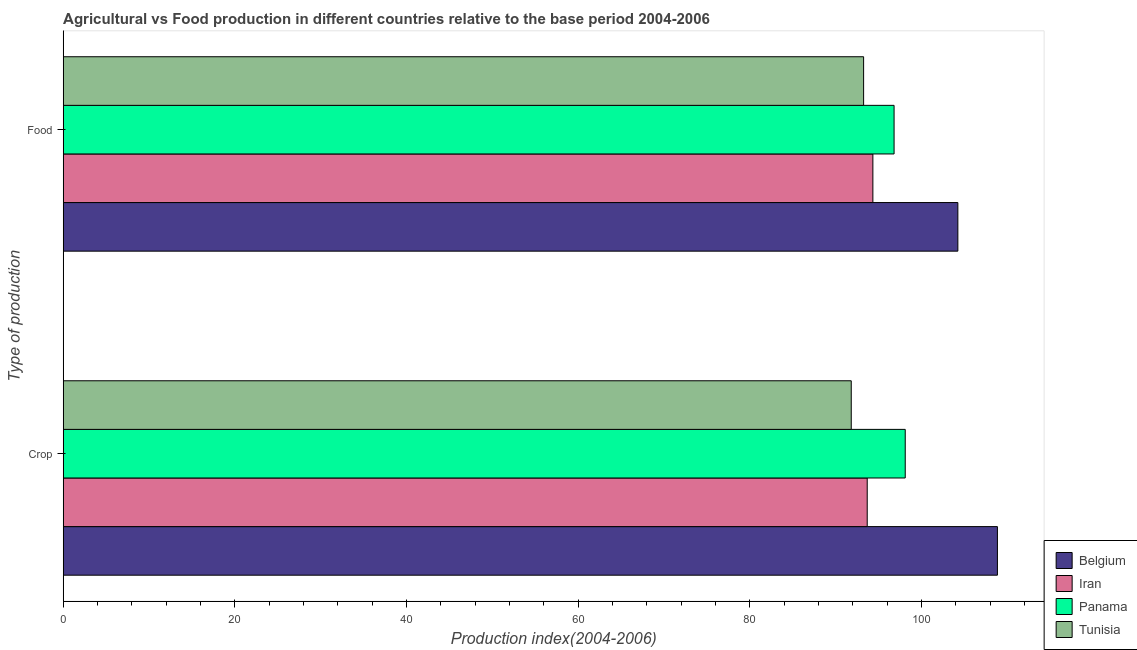Are the number of bars on each tick of the Y-axis equal?
Make the answer very short. Yes. How many bars are there on the 2nd tick from the top?
Keep it short and to the point. 4. How many bars are there on the 2nd tick from the bottom?
Provide a short and direct response. 4. What is the label of the 1st group of bars from the top?
Your response must be concise. Food. What is the crop production index in Belgium?
Offer a terse response. 108.84. Across all countries, what is the maximum crop production index?
Keep it short and to the point. 108.84. Across all countries, what is the minimum crop production index?
Offer a very short reply. 91.81. In which country was the crop production index minimum?
Offer a terse response. Tunisia. What is the total food production index in the graph?
Offer a terse response. 388.61. What is the difference between the crop production index in Tunisia and that in Iran?
Your answer should be very brief. -1.86. What is the difference between the crop production index in Tunisia and the food production index in Iran?
Your answer should be very brief. -2.52. What is the average crop production index per country?
Offer a terse response. 98.11. What is the difference between the food production index and crop production index in Iran?
Give a very brief answer. 0.66. What is the ratio of the crop production index in Belgium to that in Tunisia?
Your response must be concise. 1.19. What does the 4th bar from the top in Crop represents?
Offer a terse response. Belgium. What does the 4th bar from the bottom in Food represents?
Your response must be concise. Tunisia. What is the difference between two consecutive major ticks on the X-axis?
Give a very brief answer. 20. Are the values on the major ticks of X-axis written in scientific E-notation?
Provide a succinct answer. No. How many legend labels are there?
Your response must be concise. 4. What is the title of the graph?
Your response must be concise. Agricultural vs Food production in different countries relative to the base period 2004-2006. Does "South Asia" appear as one of the legend labels in the graph?
Your response must be concise. No. What is the label or title of the X-axis?
Your answer should be compact. Production index(2004-2006). What is the label or title of the Y-axis?
Make the answer very short. Type of production. What is the Production index(2004-2006) of Belgium in Crop?
Your response must be concise. 108.84. What is the Production index(2004-2006) in Iran in Crop?
Your answer should be very brief. 93.67. What is the Production index(2004-2006) in Panama in Crop?
Offer a very short reply. 98.1. What is the Production index(2004-2006) in Tunisia in Crop?
Ensure brevity in your answer.  91.81. What is the Production index(2004-2006) in Belgium in Food?
Your response must be concise. 104.23. What is the Production index(2004-2006) of Iran in Food?
Make the answer very short. 94.33. What is the Production index(2004-2006) of Panama in Food?
Make the answer very short. 96.8. What is the Production index(2004-2006) in Tunisia in Food?
Offer a very short reply. 93.25. Across all Type of production, what is the maximum Production index(2004-2006) of Belgium?
Your response must be concise. 108.84. Across all Type of production, what is the maximum Production index(2004-2006) in Iran?
Offer a terse response. 94.33. Across all Type of production, what is the maximum Production index(2004-2006) of Panama?
Offer a terse response. 98.1. Across all Type of production, what is the maximum Production index(2004-2006) in Tunisia?
Ensure brevity in your answer.  93.25. Across all Type of production, what is the minimum Production index(2004-2006) in Belgium?
Provide a succinct answer. 104.23. Across all Type of production, what is the minimum Production index(2004-2006) of Iran?
Make the answer very short. 93.67. Across all Type of production, what is the minimum Production index(2004-2006) in Panama?
Give a very brief answer. 96.8. Across all Type of production, what is the minimum Production index(2004-2006) in Tunisia?
Your answer should be compact. 91.81. What is the total Production index(2004-2006) of Belgium in the graph?
Your answer should be compact. 213.07. What is the total Production index(2004-2006) of Iran in the graph?
Your response must be concise. 188. What is the total Production index(2004-2006) of Panama in the graph?
Your answer should be compact. 194.9. What is the total Production index(2004-2006) of Tunisia in the graph?
Your answer should be compact. 185.06. What is the difference between the Production index(2004-2006) in Belgium in Crop and that in Food?
Give a very brief answer. 4.61. What is the difference between the Production index(2004-2006) of Iran in Crop and that in Food?
Your answer should be compact. -0.66. What is the difference between the Production index(2004-2006) of Panama in Crop and that in Food?
Provide a short and direct response. 1.3. What is the difference between the Production index(2004-2006) in Tunisia in Crop and that in Food?
Provide a succinct answer. -1.44. What is the difference between the Production index(2004-2006) of Belgium in Crop and the Production index(2004-2006) of Iran in Food?
Give a very brief answer. 14.51. What is the difference between the Production index(2004-2006) in Belgium in Crop and the Production index(2004-2006) in Panama in Food?
Provide a succinct answer. 12.04. What is the difference between the Production index(2004-2006) of Belgium in Crop and the Production index(2004-2006) of Tunisia in Food?
Make the answer very short. 15.59. What is the difference between the Production index(2004-2006) of Iran in Crop and the Production index(2004-2006) of Panama in Food?
Offer a very short reply. -3.13. What is the difference between the Production index(2004-2006) in Iran in Crop and the Production index(2004-2006) in Tunisia in Food?
Your answer should be compact. 0.42. What is the difference between the Production index(2004-2006) of Panama in Crop and the Production index(2004-2006) of Tunisia in Food?
Provide a succinct answer. 4.85. What is the average Production index(2004-2006) of Belgium per Type of production?
Offer a very short reply. 106.53. What is the average Production index(2004-2006) in Iran per Type of production?
Offer a very short reply. 94. What is the average Production index(2004-2006) of Panama per Type of production?
Your answer should be compact. 97.45. What is the average Production index(2004-2006) in Tunisia per Type of production?
Ensure brevity in your answer.  92.53. What is the difference between the Production index(2004-2006) in Belgium and Production index(2004-2006) in Iran in Crop?
Offer a very short reply. 15.17. What is the difference between the Production index(2004-2006) in Belgium and Production index(2004-2006) in Panama in Crop?
Offer a terse response. 10.74. What is the difference between the Production index(2004-2006) of Belgium and Production index(2004-2006) of Tunisia in Crop?
Keep it short and to the point. 17.03. What is the difference between the Production index(2004-2006) in Iran and Production index(2004-2006) in Panama in Crop?
Make the answer very short. -4.43. What is the difference between the Production index(2004-2006) of Iran and Production index(2004-2006) of Tunisia in Crop?
Your answer should be very brief. 1.86. What is the difference between the Production index(2004-2006) in Panama and Production index(2004-2006) in Tunisia in Crop?
Your answer should be compact. 6.29. What is the difference between the Production index(2004-2006) in Belgium and Production index(2004-2006) in Panama in Food?
Offer a very short reply. 7.43. What is the difference between the Production index(2004-2006) in Belgium and Production index(2004-2006) in Tunisia in Food?
Offer a terse response. 10.98. What is the difference between the Production index(2004-2006) of Iran and Production index(2004-2006) of Panama in Food?
Make the answer very short. -2.47. What is the difference between the Production index(2004-2006) in Iran and Production index(2004-2006) in Tunisia in Food?
Make the answer very short. 1.08. What is the difference between the Production index(2004-2006) of Panama and Production index(2004-2006) of Tunisia in Food?
Offer a very short reply. 3.55. What is the ratio of the Production index(2004-2006) of Belgium in Crop to that in Food?
Make the answer very short. 1.04. What is the ratio of the Production index(2004-2006) in Panama in Crop to that in Food?
Provide a succinct answer. 1.01. What is the ratio of the Production index(2004-2006) in Tunisia in Crop to that in Food?
Ensure brevity in your answer.  0.98. What is the difference between the highest and the second highest Production index(2004-2006) of Belgium?
Offer a terse response. 4.61. What is the difference between the highest and the second highest Production index(2004-2006) in Iran?
Your answer should be compact. 0.66. What is the difference between the highest and the second highest Production index(2004-2006) in Tunisia?
Provide a short and direct response. 1.44. What is the difference between the highest and the lowest Production index(2004-2006) in Belgium?
Provide a succinct answer. 4.61. What is the difference between the highest and the lowest Production index(2004-2006) in Iran?
Your response must be concise. 0.66. What is the difference between the highest and the lowest Production index(2004-2006) of Tunisia?
Offer a very short reply. 1.44. 